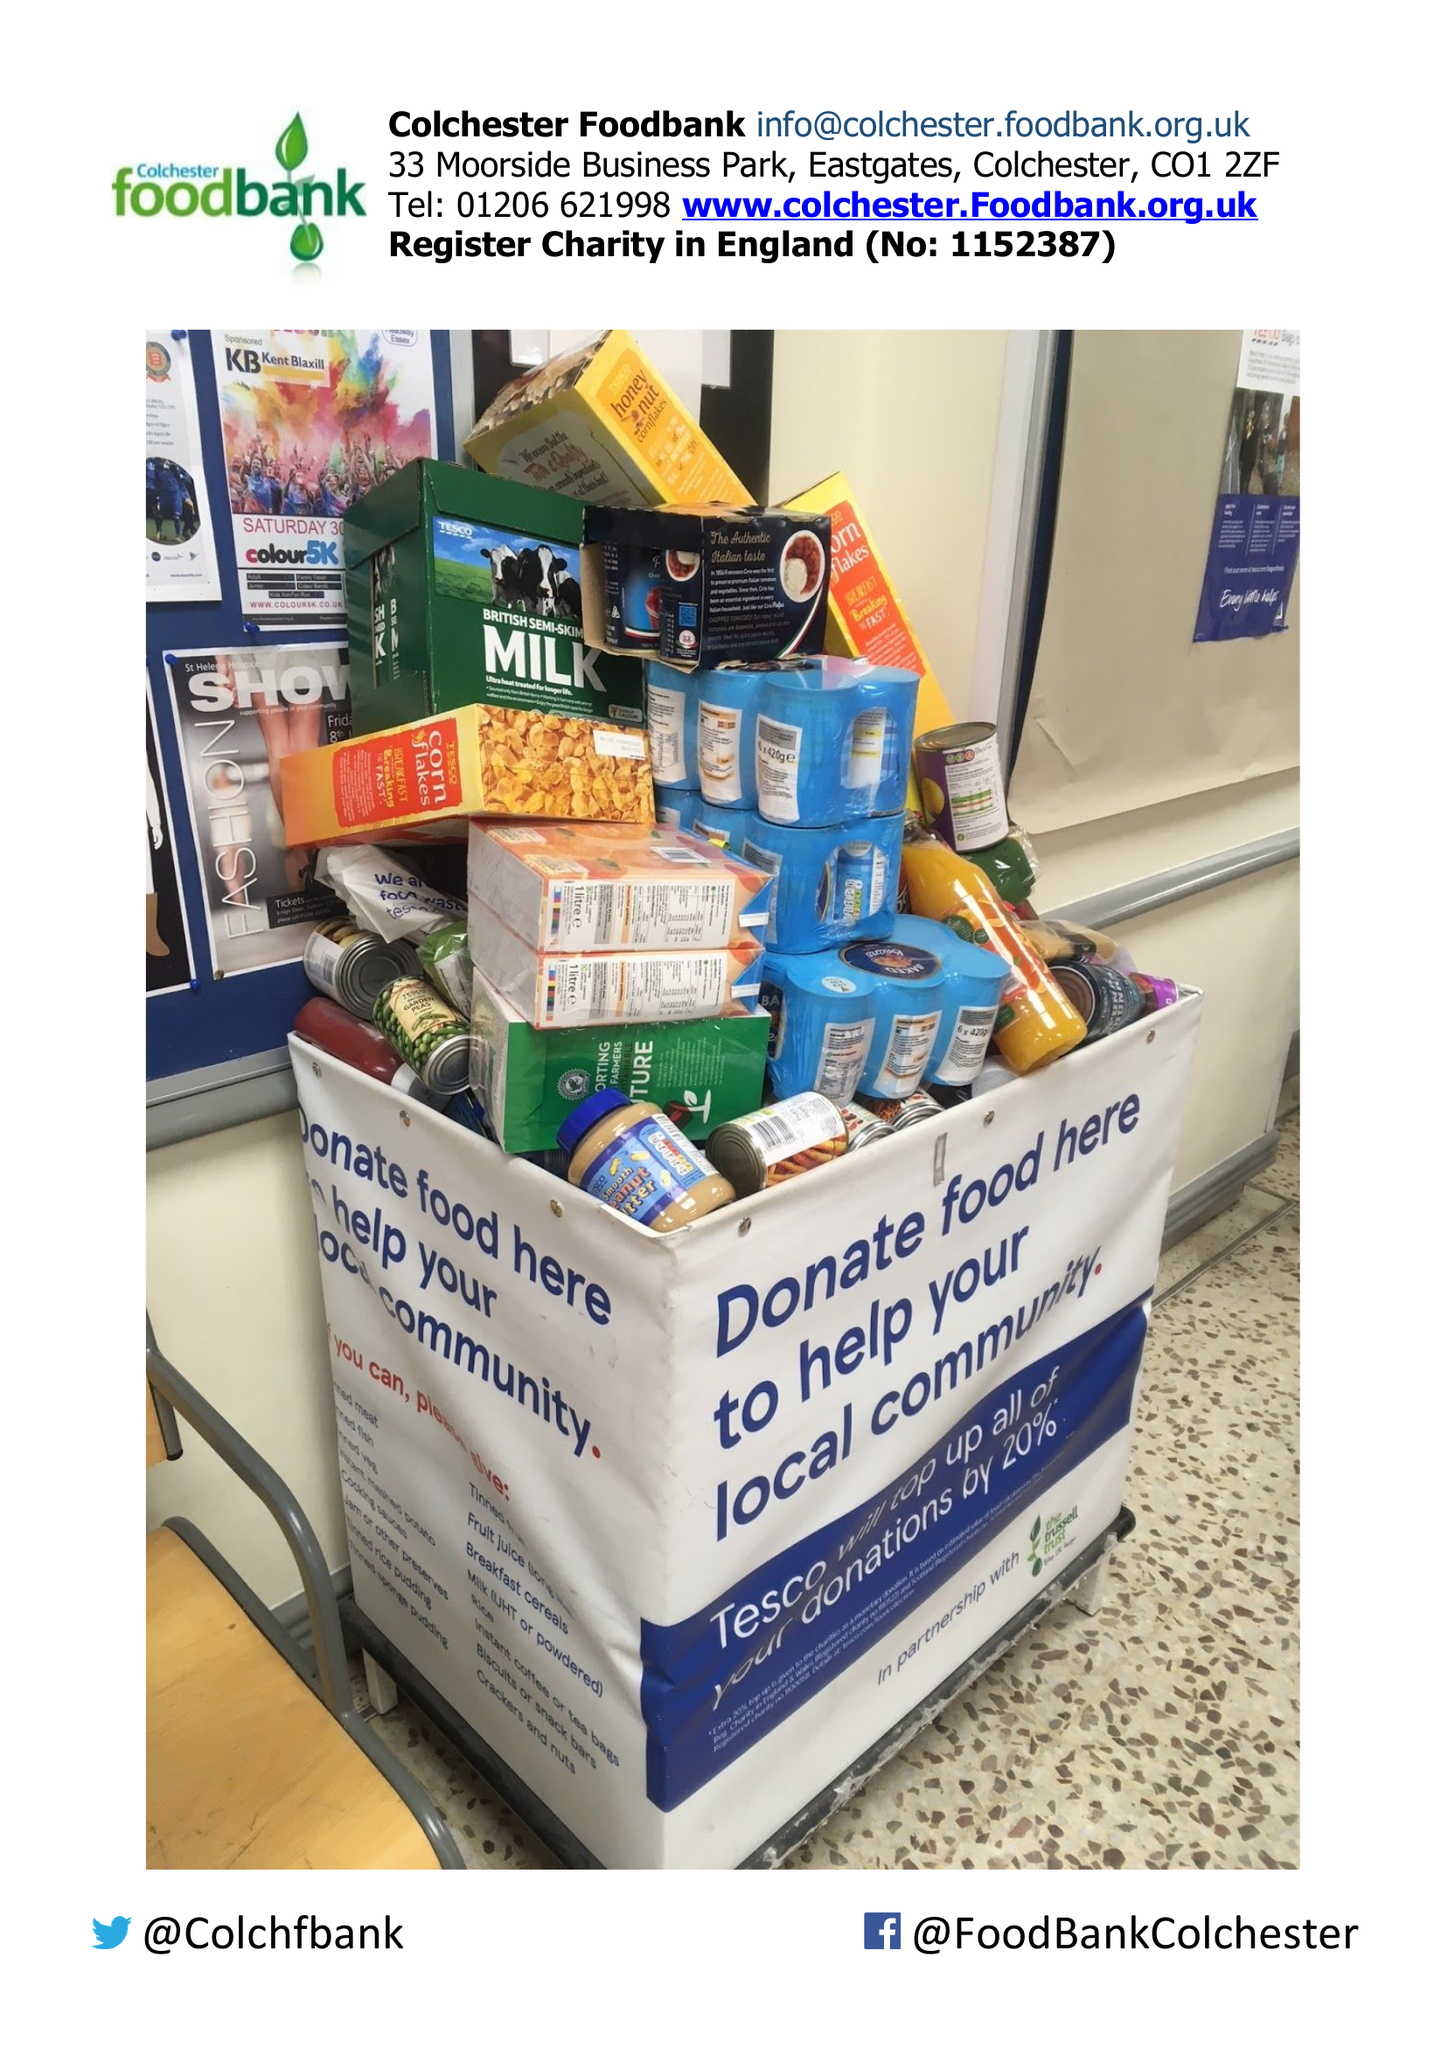What is the value for the address__street_line?
Answer the question using a single word or phrase. 9 BLACKWATER AVENUE 